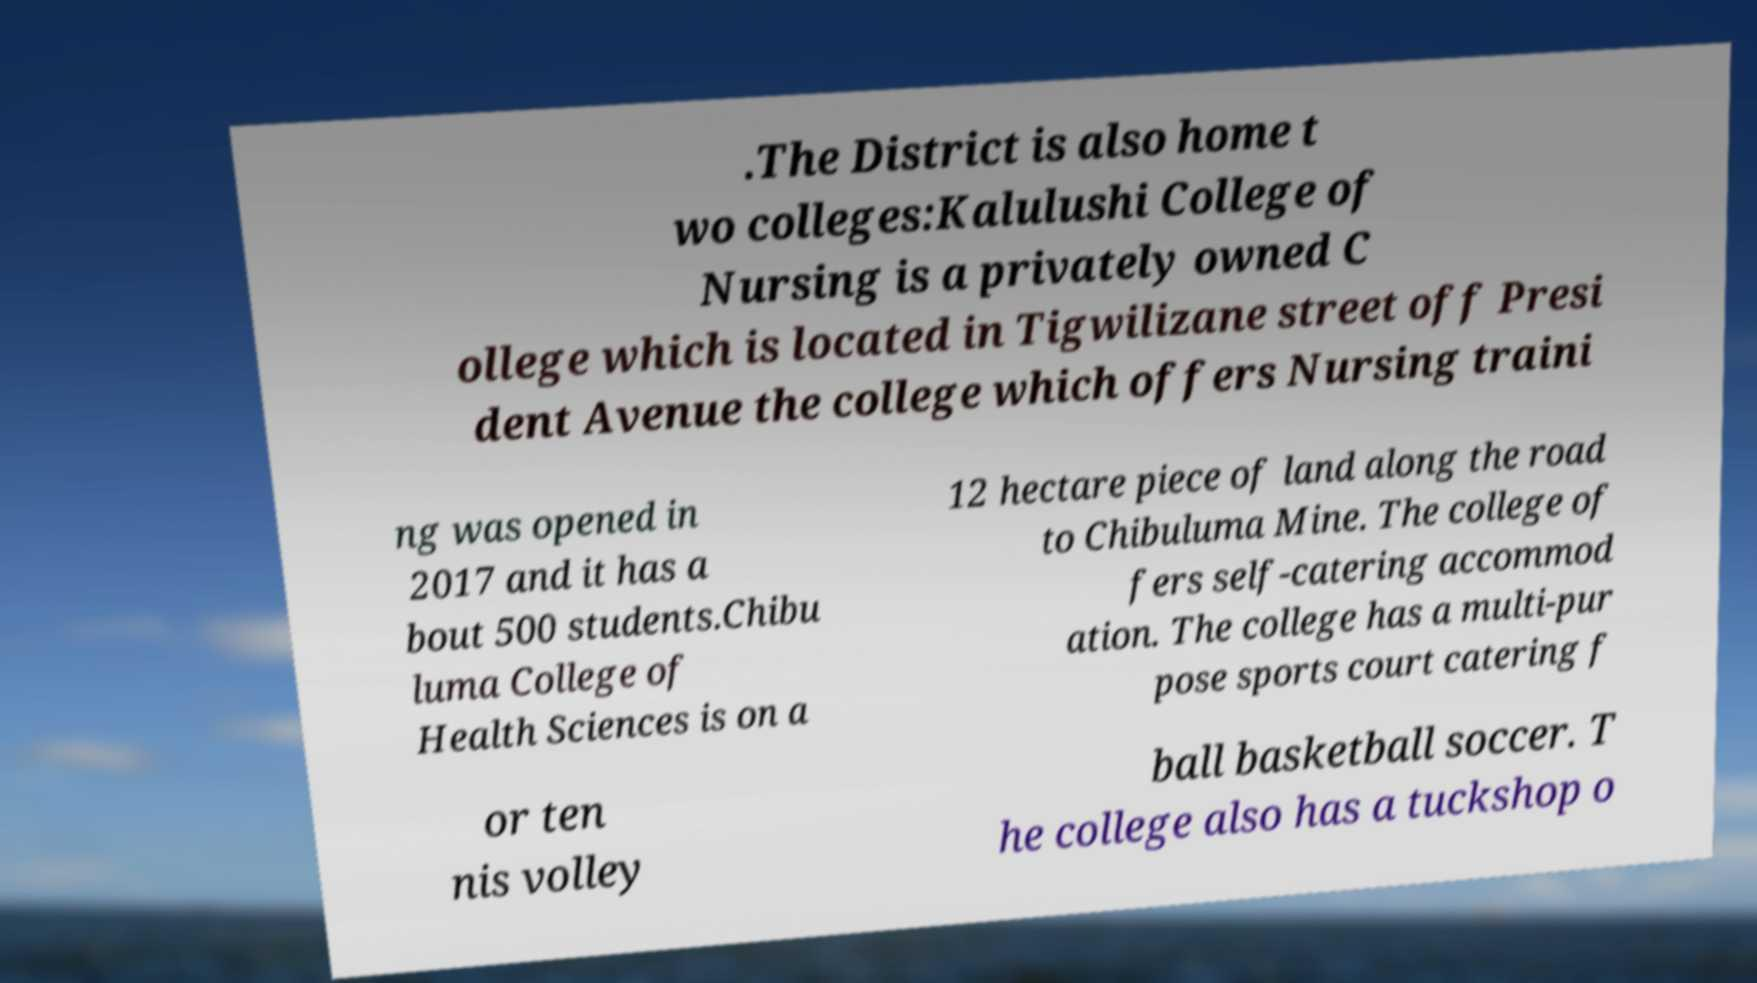I need the written content from this picture converted into text. Can you do that? .The District is also home t wo colleges:Kalulushi College of Nursing is a privately owned C ollege which is located in Tigwilizane street off Presi dent Avenue the college which offers Nursing traini ng was opened in 2017 and it has a bout 500 students.Chibu luma College of Health Sciences is on a 12 hectare piece of land along the road to Chibuluma Mine. The college of fers self-catering accommod ation. The college has a multi-pur pose sports court catering f or ten nis volley ball basketball soccer. T he college also has a tuckshop o 